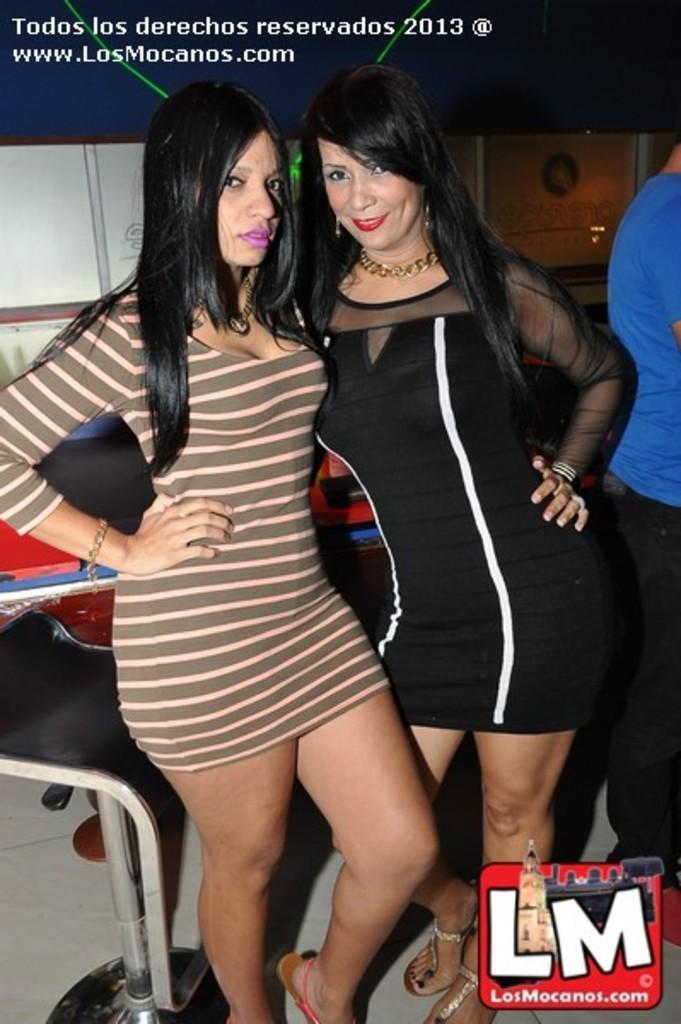Describe this image in one or two sentences. This image consists of two women. At the bottom, there is a floor. On the left, there is a chair. On the right, we can see another person wearing a blue T-shirt. 